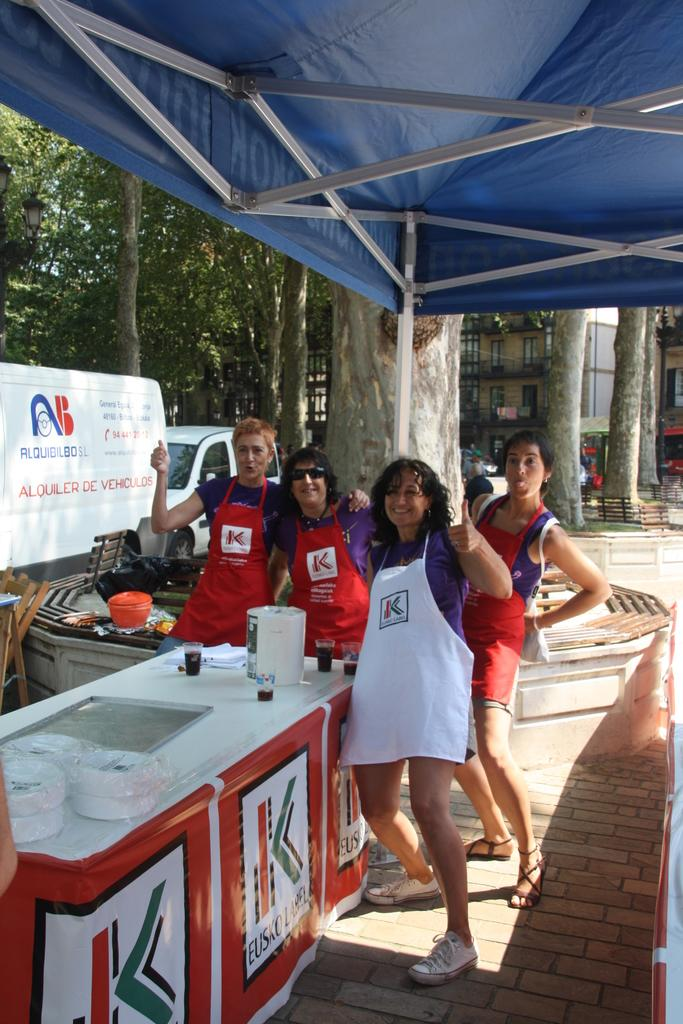<image>
Describe the image concisely. paople posing in fron of a van with alquiler on it 